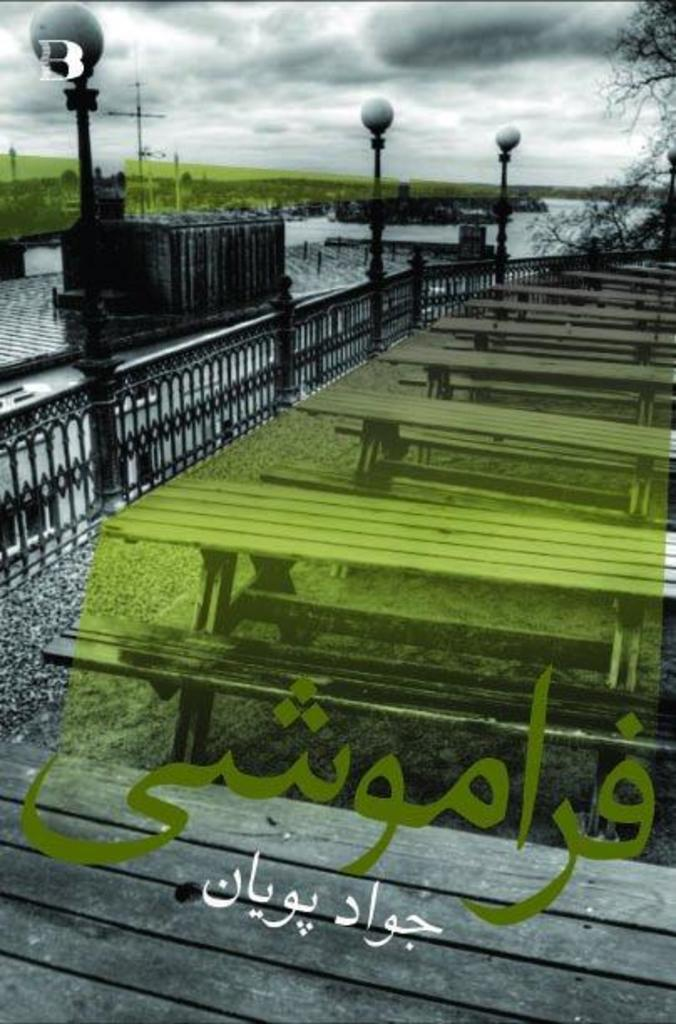What type of furniture is present in the image? There are benches and tables in the image. What other structures can be seen in the image? There are poles and railing in the image. What natural elements are visible in the image? Water, trees, and the sky are visible in the image. What is the color of the path in the image? There is a black color object on a wooden path in the image. What is written on the black color object? Something is written on the black color object. Can you tell me how many times your sister has smashed a park bench in the image? There is no mention of a sister or any smashing in the image. The image only shows benches, tables, poles, railing, water, trees, sky, a wooden path, and a black color object with writing on it. 